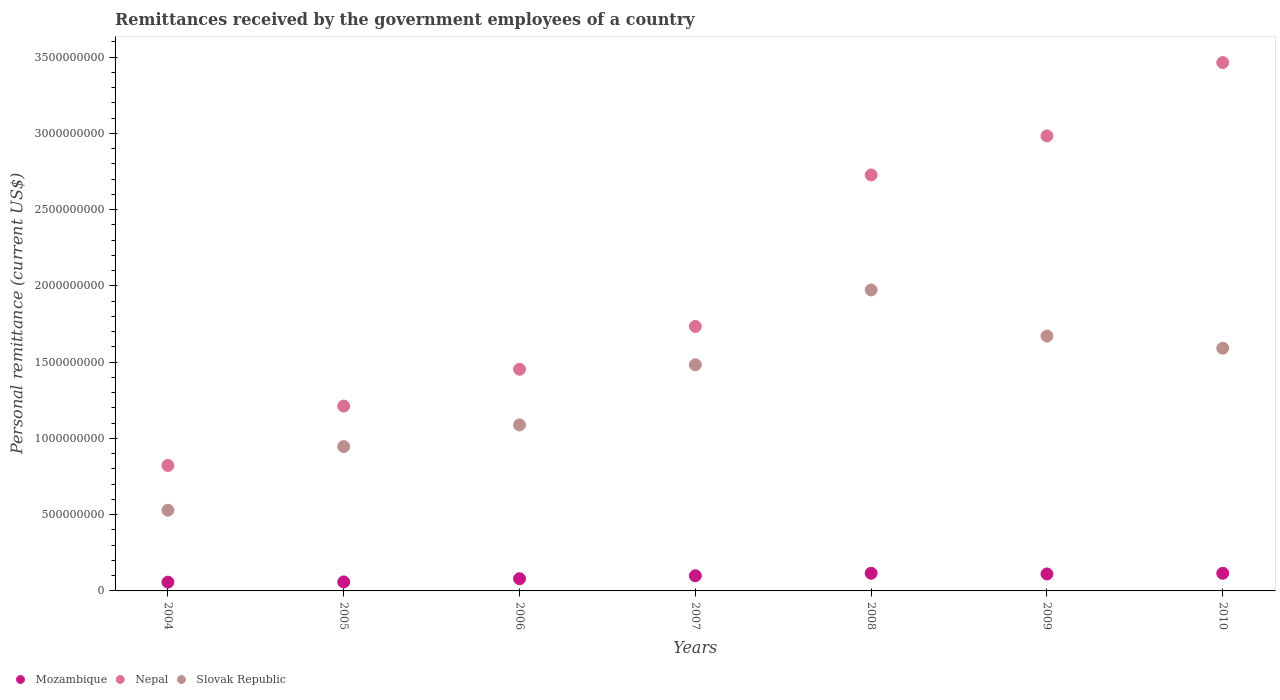How many different coloured dotlines are there?
Your answer should be very brief. 3. What is the remittances received by the government employees in Slovak Republic in 2006?
Offer a terse response. 1.09e+09. Across all years, what is the maximum remittances received by the government employees in Mozambique?
Keep it short and to the point. 1.16e+08. Across all years, what is the minimum remittances received by the government employees in Nepal?
Keep it short and to the point. 8.23e+08. In which year was the remittances received by the government employees in Nepal maximum?
Your answer should be very brief. 2010. In which year was the remittances received by the government employees in Slovak Republic minimum?
Your response must be concise. 2004. What is the total remittances received by the government employees in Nepal in the graph?
Make the answer very short. 1.44e+1. What is the difference between the remittances received by the government employees in Slovak Republic in 2007 and that in 2010?
Ensure brevity in your answer.  -1.09e+08. What is the difference between the remittances received by the government employees in Mozambique in 2009 and the remittances received by the government employees in Nepal in 2007?
Make the answer very short. -1.62e+09. What is the average remittances received by the government employees in Nepal per year?
Give a very brief answer. 2.06e+09. In the year 2008, what is the difference between the remittances received by the government employees in Slovak Republic and remittances received by the government employees in Nepal?
Provide a short and direct response. -7.54e+08. What is the ratio of the remittances received by the government employees in Nepal in 2008 to that in 2010?
Offer a terse response. 0.79. What is the difference between the highest and the second highest remittances received by the government employees in Slovak Republic?
Provide a short and direct response. 3.02e+08. What is the difference between the highest and the lowest remittances received by the government employees in Slovak Republic?
Provide a short and direct response. 1.44e+09. In how many years, is the remittances received by the government employees in Mozambique greater than the average remittances received by the government employees in Mozambique taken over all years?
Provide a short and direct response. 4. Is the remittances received by the government employees in Slovak Republic strictly greater than the remittances received by the government employees in Mozambique over the years?
Offer a very short reply. Yes. How many dotlines are there?
Make the answer very short. 3. What is the difference between two consecutive major ticks on the Y-axis?
Provide a succinct answer. 5.00e+08. Does the graph contain any zero values?
Offer a terse response. No. Does the graph contain grids?
Offer a very short reply. No. How many legend labels are there?
Your answer should be very brief. 3. How are the legend labels stacked?
Provide a succinct answer. Horizontal. What is the title of the graph?
Provide a succinct answer. Remittances received by the government employees of a country. What is the label or title of the Y-axis?
Provide a short and direct response. Personal remittance (current US$). What is the Personal remittance (current US$) of Mozambique in 2004?
Offer a terse response. 5.75e+07. What is the Personal remittance (current US$) in Nepal in 2004?
Your answer should be compact. 8.23e+08. What is the Personal remittance (current US$) of Slovak Republic in 2004?
Keep it short and to the point. 5.29e+08. What is the Personal remittance (current US$) of Mozambique in 2005?
Provide a short and direct response. 5.89e+07. What is the Personal remittance (current US$) of Nepal in 2005?
Make the answer very short. 1.21e+09. What is the Personal remittance (current US$) of Slovak Republic in 2005?
Ensure brevity in your answer.  9.46e+08. What is the Personal remittance (current US$) of Mozambique in 2006?
Provide a succinct answer. 8.00e+07. What is the Personal remittance (current US$) of Nepal in 2006?
Give a very brief answer. 1.45e+09. What is the Personal remittance (current US$) of Slovak Republic in 2006?
Provide a short and direct response. 1.09e+09. What is the Personal remittance (current US$) of Mozambique in 2007?
Make the answer very short. 9.94e+07. What is the Personal remittance (current US$) in Nepal in 2007?
Keep it short and to the point. 1.73e+09. What is the Personal remittance (current US$) in Slovak Republic in 2007?
Provide a short and direct response. 1.48e+09. What is the Personal remittance (current US$) of Mozambique in 2008?
Offer a very short reply. 1.16e+08. What is the Personal remittance (current US$) in Nepal in 2008?
Your answer should be very brief. 2.73e+09. What is the Personal remittance (current US$) of Slovak Republic in 2008?
Offer a terse response. 1.97e+09. What is the Personal remittance (current US$) in Mozambique in 2009?
Offer a very short reply. 1.11e+08. What is the Personal remittance (current US$) of Nepal in 2009?
Give a very brief answer. 2.98e+09. What is the Personal remittance (current US$) in Slovak Republic in 2009?
Provide a succinct answer. 1.67e+09. What is the Personal remittance (current US$) in Mozambique in 2010?
Offer a terse response. 1.16e+08. What is the Personal remittance (current US$) of Nepal in 2010?
Offer a terse response. 3.46e+09. What is the Personal remittance (current US$) in Slovak Republic in 2010?
Offer a very short reply. 1.59e+09. Across all years, what is the maximum Personal remittance (current US$) of Mozambique?
Offer a terse response. 1.16e+08. Across all years, what is the maximum Personal remittance (current US$) of Nepal?
Ensure brevity in your answer.  3.46e+09. Across all years, what is the maximum Personal remittance (current US$) in Slovak Republic?
Make the answer very short. 1.97e+09. Across all years, what is the minimum Personal remittance (current US$) of Mozambique?
Your response must be concise. 5.75e+07. Across all years, what is the minimum Personal remittance (current US$) in Nepal?
Your answer should be compact. 8.23e+08. Across all years, what is the minimum Personal remittance (current US$) in Slovak Republic?
Your response must be concise. 5.29e+08. What is the total Personal remittance (current US$) in Mozambique in the graph?
Ensure brevity in your answer.  6.38e+08. What is the total Personal remittance (current US$) of Nepal in the graph?
Ensure brevity in your answer.  1.44e+1. What is the total Personal remittance (current US$) in Slovak Republic in the graph?
Keep it short and to the point. 9.28e+09. What is the difference between the Personal remittance (current US$) in Mozambique in 2004 and that in 2005?
Your response must be concise. -1.37e+06. What is the difference between the Personal remittance (current US$) in Nepal in 2004 and that in 2005?
Your answer should be compact. -3.89e+08. What is the difference between the Personal remittance (current US$) in Slovak Republic in 2004 and that in 2005?
Offer a very short reply. -4.17e+08. What is the difference between the Personal remittance (current US$) of Mozambique in 2004 and that in 2006?
Provide a short and direct response. -2.25e+07. What is the difference between the Personal remittance (current US$) of Nepal in 2004 and that in 2006?
Keep it short and to the point. -6.31e+08. What is the difference between the Personal remittance (current US$) in Slovak Republic in 2004 and that in 2006?
Your response must be concise. -5.59e+08. What is the difference between the Personal remittance (current US$) of Mozambique in 2004 and that in 2007?
Offer a very short reply. -4.19e+07. What is the difference between the Personal remittance (current US$) in Nepal in 2004 and that in 2007?
Make the answer very short. -9.11e+08. What is the difference between the Personal remittance (current US$) of Slovak Republic in 2004 and that in 2007?
Give a very brief answer. -9.54e+08. What is the difference between the Personal remittance (current US$) of Mozambique in 2004 and that in 2008?
Make the answer very short. -5.82e+07. What is the difference between the Personal remittance (current US$) of Nepal in 2004 and that in 2008?
Ensure brevity in your answer.  -1.90e+09. What is the difference between the Personal remittance (current US$) in Slovak Republic in 2004 and that in 2008?
Your response must be concise. -1.44e+09. What is the difference between the Personal remittance (current US$) in Mozambique in 2004 and that in 2009?
Make the answer very short. -5.36e+07. What is the difference between the Personal remittance (current US$) in Nepal in 2004 and that in 2009?
Offer a very short reply. -2.16e+09. What is the difference between the Personal remittance (current US$) of Slovak Republic in 2004 and that in 2009?
Make the answer very short. -1.14e+09. What is the difference between the Personal remittance (current US$) of Mozambique in 2004 and that in 2010?
Give a very brief answer. -5.83e+07. What is the difference between the Personal remittance (current US$) of Nepal in 2004 and that in 2010?
Your answer should be very brief. -2.64e+09. What is the difference between the Personal remittance (current US$) in Slovak Republic in 2004 and that in 2010?
Ensure brevity in your answer.  -1.06e+09. What is the difference between the Personal remittance (current US$) of Mozambique in 2005 and that in 2006?
Your response must be concise. -2.11e+07. What is the difference between the Personal remittance (current US$) of Nepal in 2005 and that in 2006?
Your answer should be very brief. -2.41e+08. What is the difference between the Personal remittance (current US$) in Slovak Republic in 2005 and that in 2006?
Your answer should be very brief. -1.42e+08. What is the difference between the Personal remittance (current US$) in Mozambique in 2005 and that in 2007?
Your answer should be compact. -4.05e+07. What is the difference between the Personal remittance (current US$) in Nepal in 2005 and that in 2007?
Offer a very short reply. -5.22e+08. What is the difference between the Personal remittance (current US$) of Slovak Republic in 2005 and that in 2007?
Give a very brief answer. -5.36e+08. What is the difference between the Personal remittance (current US$) of Mozambique in 2005 and that in 2008?
Your answer should be compact. -5.69e+07. What is the difference between the Personal remittance (current US$) in Nepal in 2005 and that in 2008?
Your response must be concise. -1.52e+09. What is the difference between the Personal remittance (current US$) of Slovak Republic in 2005 and that in 2008?
Ensure brevity in your answer.  -1.03e+09. What is the difference between the Personal remittance (current US$) in Mozambique in 2005 and that in 2009?
Offer a terse response. -5.22e+07. What is the difference between the Personal remittance (current US$) in Nepal in 2005 and that in 2009?
Offer a terse response. -1.77e+09. What is the difference between the Personal remittance (current US$) in Slovak Republic in 2005 and that in 2009?
Your answer should be very brief. -7.24e+08. What is the difference between the Personal remittance (current US$) in Mozambique in 2005 and that in 2010?
Make the answer very short. -5.69e+07. What is the difference between the Personal remittance (current US$) in Nepal in 2005 and that in 2010?
Your answer should be compact. -2.25e+09. What is the difference between the Personal remittance (current US$) of Slovak Republic in 2005 and that in 2010?
Provide a succinct answer. -6.45e+08. What is the difference between the Personal remittance (current US$) in Mozambique in 2006 and that in 2007?
Your answer should be very brief. -1.94e+07. What is the difference between the Personal remittance (current US$) in Nepal in 2006 and that in 2007?
Your response must be concise. -2.81e+08. What is the difference between the Personal remittance (current US$) of Slovak Republic in 2006 and that in 2007?
Provide a short and direct response. -3.94e+08. What is the difference between the Personal remittance (current US$) of Mozambique in 2006 and that in 2008?
Offer a very short reply. -3.57e+07. What is the difference between the Personal remittance (current US$) in Nepal in 2006 and that in 2008?
Provide a short and direct response. -1.27e+09. What is the difference between the Personal remittance (current US$) in Slovak Republic in 2006 and that in 2008?
Provide a succinct answer. -8.85e+08. What is the difference between the Personal remittance (current US$) of Mozambique in 2006 and that in 2009?
Give a very brief answer. -3.11e+07. What is the difference between the Personal remittance (current US$) of Nepal in 2006 and that in 2009?
Your response must be concise. -1.53e+09. What is the difference between the Personal remittance (current US$) of Slovak Republic in 2006 and that in 2009?
Give a very brief answer. -5.83e+08. What is the difference between the Personal remittance (current US$) of Mozambique in 2006 and that in 2010?
Your response must be concise. -3.57e+07. What is the difference between the Personal remittance (current US$) of Nepal in 2006 and that in 2010?
Make the answer very short. -2.01e+09. What is the difference between the Personal remittance (current US$) of Slovak Republic in 2006 and that in 2010?
Your answer should be very brief. -5.03e+08. What is the difference between the Personal remittance (current US$) of Mozambique in 2007 and that in 2008?
Provide a short and direct response. -1.64e+07. What is the difference between the Personal remittance (current US$) of Nepal in 2007 and that in 2008?
Provide a short and direct response. -9.93e+08. What is the difference between the Personal remittance (current US$) of Slovak Republic in 2007 and that in 2008?
Offer a terse response. -4.91e+08. What is the difference between the Personal remittance (current US$) of Mozambique in 2007 and that in 2009?
Offer a very short reply. -1.17e+07. What is the difference between the Personal remittance (current US$) of Nepal in 2007 and that in 2009?
Give a very brief answer. -1.25e+09. What is the difference between the Personal remittance (current US$) in Slovak Republic in 2007 and that in 2009?
Keep it short and to the point. -1.88e+08. What is the difference between the Personal remittance (current US$) in Mozambique in 2007 and that in 2010?
Provide a succinct answer. -1.64e+07. What is the difference between the Personal remittance (current US$) of Nepal in 2007 and that in 2010?
Provide a short and direct response. -1.73e+09. What is the difference between the Personal remittance (current US$) of Slovak Republic in 2007 and that in 2010?
Offer a very short reply. -1.09e+08. What is the difference between the Personal remittance (current US$) of Mozambique in 2008 and that in 2009?
Keep it short and to the point. 4.62e+06. What is the difference between the Personal remittance (current US$) of Nepal in 2008 and that in 2009?
Give a very brief answer. -2.56e+08. What is the difference between the Personal remittance (current US$) in Slovak Republic in 2008 and that in 2009?
Make the answer very short. 3.02e+08. What is the difference between the Personal remittance (current US$) of Mozambique in 2008 and that in 2010?
Provide a short and direct response. -3.33e+04. What is the difference between the Personal remittance (current US$) of Nepal in 2008 and that in 2010?
Keep it short and to the point. -7.37e+08. What is the difference between the Personal remittance (current US$) in Slovak Republic in 2008 and that in 2010?
Make the answer very short. 3.82e+08. What is the difference between the Personal remittance (current US$) in Mozambique in 2009 and that in 2010?
Your response must be concise. -4.65e+06. What is the difference between the Personal remittance (current US$) in Nepal in 2009 and that in 2010?
Make the answer very short. -4.81e+08. What is the difference between the Personal remittance (current US$) of Slovak Republic in 2009 and that in 2010?
Your answer should be compact. 7.96e+07. What is the difference between the Personal remittance (current US$) in Mozambique in 2004 and the Personal remittance (current US$) in Nepal in 2005?
Provide a short and direct response. -1.15e+09. What is the difference between the Personal remittance (current US$) in Mozambique in 2004 and the Personal remittance (current US$) in Slovak Republic in 2005?
Offer a very short reply. -8.89e+08. What is the difference between the Personal remittance (current US$) of Nepal in 2004 and the Personal remittance (current US$) of Slovak Republic in 2005?
Provide a succinct answer. -1.24e+08. What is the difference between the Personal remittance (current US$) in Mozambique in 2004 and the Personal remittance (current US$) in Nepal in 2006?
Make the answer very short. -1.40e+09. What is the difference between the Personal remittance (current US$) in Mozambique in 2004 and the Personal remittance (current US$) in Slovak Republic in 2006?
Give a very brief answer. -1.03e+09. What is the difference between the Personal remittance (current US$) of Nepal in 2004 and the Personal remittance (current US$) of Slovak Republic in 2006?
Provide a short and direct response. -2.66e+08. What is the difference between the Personal remittance (current US$) in Mozambique in 2004 and the Personal remittance (current US$) in Nepal in 2007?
Keep it short and to the point. -1.68e+09. What is the difference between the Personal remittance (current US$) of Mozambique in 2004 and the Personal remittance (current US$) of Slovak Republic in 2007?
Your answer should be compact. -1.43e+09. What is the difference between the Personal remittance (current US$) of Nepal in 2004 and the Personal remittance (current US$) of Slovak Republic in 2007?
Provide a succinct answer. -6.60e+08. What is the difference between the Personal remittance (current US$) in Mozambique in 2004 and the Personal remittance (current US$) in Nepal in 2008?
Your answer should be compact. -2.67e+09. What is the difference between the Personal remittance (current US$) of Mozambique in 2004 and the Personal remittance (current US$) of Slovak Republic in 2008?
Your answer should be very brief. -1.92e+09. What is the difference between the Personal remittance (current US$) of Nepal in 2004 and the Personal remittance (current US$) of Slovak Republic in 2008?
Your answer should be compact. -1.15e+09. What is the difference between the Personal remittance (current US$) in Mozambique in 2004 and the Personal remittance (current US$) in Nepal in 2009?
Your answer should be very brief. -2.93e+09. What is the difference between the Personal remittance (current US$) in Mozambique in 2004 and the Personal remittance (current US$) in Slovak Republic in 2009?
Offer a very short reply. -1.61e+09. What is the difference between the Personal remittance (current US$) of Nepal in 2004 and the Personal remittance (current US$) of Slovak Republic in 2009?
Offer a terse response. -8.48e+08. What is the difference between the Personal remittance (current US$) in Mozambique in 2004 and the Personal remittance (current US$) in Nepal in 2010?
Your answer should be very brief. -3.41e+09. What is the difference between the Personal remittance (current US$) of Mozambique in 2004 and the Personal remittance (current US$) of Slovak Republic in 2010?
Provide a succinct answer. -1.53e+09. What is the difference between the Personal remittance (current US$) in Nepal in 2004 and the Personal remittance (current US$) in Slovak Republic in 2010?
Offer a terse response. -7.69e+08. What is the difference between the Personal remittance (current US$) of Mozambique in 2005 and the Personal remittance (current US$) of Nepal in 2006?
Provide a short and direct response. -1.39e+09. What is the difference between the Personal remittance (current US$) of Mozambique in 2005 and the Personal remittance (current US$) of Slovak Republic in 2006?
Your response must be concise. -1.03e+09. What is the difference between the Personal remittance (current US$) in Nepal in 2005 and the Personal remittance (current US$) in Slovak Republic in 2006?
Ensure brevity in your answer.  1.24e+08. What is the difference between the Personal remittance (current US$) of Mozambique in 2005 and the Personal remittance (current US$) of Nepal in 2007?
Keep it short and to the point. -1.67e+09. What is the difference between the Personal remittance (current US$) in Mozambique in 2005 and the Personal remittance (current US$) in Slovak Republic in 2007?
Provide a succinct answer. -1.42e+09. What is the difference between the Personal remittance (current US$) of Nepal in 2005 and the Personal remittance (current US$) of Slovak Republic in 2007?
Your answer should be very brief. -2.71e+08. What is the difference between the Personal remittance (current US$) of Mozambique in 2005 and the Personal remittance (current US$) of Nepal in 2008?
Your answer should be compact. -2.67e+09. What is the difference between the Personal remittance (current US$) in Mozambique in 2005 and the Personal remittance (current US$) in Slovak Republic in 2008?
Provide a short and direct response. -1.91e+09. What is the difference between the Personal remittance (current US$) in Nepal in 2005 and the Personal remittance (current US$) in Slovak Republic in 2008?
Offer a very short reply. -7.61e+08. What is the difference between the Personal remittance (current US$) of Mozambique in 2005 and the Personal remittance (current US$) of Nepal in 2009?
Provide a succinct answer. -2.92e+09. What is the difference between the Personal remittance (current US$) of Mozambique in 2005 and the Personal remittance (current US$) of Slovak Republic in 2009?
Offer a very short reply. -1.61e+09. What is the difference between the Personal remittance (current US$) of Nepal in 2005 and the Personal remittance (current US$) of Slovak Republic in 2009?
Offer a terse response. -4.59e+08. What is the difference between the Personal remittance (current US$) of Mozambique in 2005 and the Personal remittance (current US$) of Nepal in 2010?
Give a very brief answer. -3.41e+09. What is the difference between the Personal remittance (current US$) in Mozambique in 2005 and the Personal remittance (current US$) in Slovak Republic in 2010?
Keep it short and to the point. -1.53e+09. What is the difference between the Personal remittance (current US$) in Nepal in 2005 and the Personal remittance (current US$) in Slovak Republic in 2010?
Your response must be concise. -3.79e+08. What is the difference between the Personal remittance (current US$) in Mozambique in 2006 and the Personal remittance (current US$) in Nepal in 2007?
Offer a very short reply. -1.65e+09. What is the difference between the Personal remittance (current US$) of Mozambique in 2006 and the Personal remittance (current US$) of Slovak Republic in 2007?
Your response must be concise. -1.40e+09. What is the difference between the Personal remittance (current US$) in Nepal in 2006 and the Personal remittance (current US$) in Slovak Republic in 2007?
Offer a terse response. -2.94e+07. What is the difference between the Personal remittance (current US$) in Mozambique in 2006 and the Personal remittance (current US$) in Nepal in 2008?
Keep it short and to the point. -2.65e+09. What is the difference between the Personal remittance (current US$) of Mozambique in 2006 and the Personal remittance (current US$) of Slovak Republic in 2008?
Make the answer very short. -1.89e+09. What is the difference between the Personal remittance (current US$) in Nepal in 2006 and the Personal remittance (current US$) in Slovak Republic in 2008?
Give a very brief answer. -5.20e+08. What is the difference between the Personal remittance (current US$) of Mozambique in 2006 and the Personal remittance (current US$) of Nepal in 2009?
Ensure brevity in your answer.  -2.90e+09. What is the difference between the Personal remittance (current US$) in Mozambique in 2006 and the Personal remittance (current US$) in Slovak Republic in 2009?
Make the answer very short. -1.59e+09. What is the difference between the Personal remittance (current US$) in Nepal in 2006 and the Personal remittance (current US$) in Slovak Republic in 2009?
Offer a terse response. -2.18e+08. What is the difference between the Personal remittance (current US$) of Mozambique in 2006 and the Personal remittance (current US$) of Nepal in 2010?
Ensure brevity in your answer.  -3.38e+09. What is the difference between the Personal remittance (current US$) in Mozambique in 2006 and the Personal remittance (current US$) in Slovak Republic in 2010?
Give a very brief answer. -1.51e+09. What is the difference between the Personal remittance (current US$) in Nepal in 2006 and the Personal remittance (current US$) in Slovak Republic in 2010?
Your response must be concise. -1.38e+08. What is the difference between the Personal remittance (current US$) in Mozambique in 2007 and the Personal remittance (current US$) in Nepal in 2008?
Give a very brief answer. -2.63e+09. What is the difference between the Personal remittance (current US$) of Mozambique in 2007 and the Personal remittance (current US$) of Slovak Republic in 2008?
Offer a terse response. -1.87e+09. What is the difference between the Personal remittance (current US$) in Nepal in 2007 and the Personal remittance (current US$) in Slovak Republic in 2008?
Provide a short and direct response. -2.39e+08. What is the difference between the Personal remittance (current US$) of Mozambique in 2007 and the Personal remittance (current US$) of Nepal in 2009?
Give a very brief answer. -2.88e+09. What is the difference between the Personal remittance (current US$) of Mozambique in 2007 and the Personal remittance (current US$) of Slovak Republic in 2009?
Provide a succinct answer. -1.57e+09. What is the difference between the Personal remittance (current US$) of Nepal in 2007 and the Personal remittance (current US$) of Slovak Republic in 2009?
Ensure brevity in your answer.  6.29e+07. What is the difference between the Personal remittance (current US$) of Mozambique in 2007 and the Personal remittance (current US$) of Nepal in 2010?
Ensure brevity in your answer.  -3.36e+09. What is the difference between the Personal remittance (current US$) of Mozambique in 2007 and the Personal remittance (current US$) of Slovak Republic in 2010?
Your answer should be compact. -1.49e+09. What is the difference between the Personal remittance (current US$) in Nepal in 2007 and the Personal remittance (current US$) in Slovak Republic in 2010?
Keep it short and to the point. 1.43e+08. What is the difference between the Personal remittance (current US$) in Mozambique in 2008 and the Personal remittance (current US$) in Nepal in 2009?
Offer a terse response. -2.87e+09. What is the difference between the Personal remittance (current US$) of Mozambique in 2008 and the Personal remittance (current US$) of Slovak Republic in 2009?
Provide a succinct answer. -1.56e+09. What is the difference between the Personal remittance (current US$) in Nepal in 2008 and the Personal remittance (current US$) in Slovak Republic in 2009?
Provide a short and direct response. 1.06e+09. What is the difference between the Personal remittance (current US$) of Mozambique in 2008 and the Personal remittance (current US$) of Nepal in 2010?
Make the answer very short. -3.35e+09. What is the difference between the Personal remittance (current US$) of Mozambique in 2008 and the Personal remittance (current US$) of Slovak Republic in 2010?
Your answer should be compact. -1.48e+09. What is the difference between the Personal remittance (current US$) in Nepal in 2008 and the Personal remittance (current US$) in Slovak Republic in 2010?
Offer a terse response. 1.14e+09. What is the difference between the Personal remittance (current US$) of Mozambique in 2009 and the Personal remittance (current US$) of Nepal in 2010?
Your answer should be very brief. -3.35e+09. What is the difference between the Personal remittance (current US$) in Mozambique in 2009 and the Personal remittance (current US$) in Slovak Republic in 2010?
Give a very brief answer. -1.48e+09. What is the difference between the Personal remittance (current US$) in Nepal in 2009 and the Personal remittance (current US$) in Slovak Republic in 2010?
Give a very brief answer. 1.39e+09. What is the average Personal remittance (current US$) of Mozambique per year?
Give a very brief answer. 9.12e+07. What is the average Personal remittance (current US$) in Nepal per year?
Make the answer very short. 2.06e+09. What is the average Personal remittance (current US$) in Slovak Republic per year?
Ensure brevity in your answer.  1.33e+09. In the year 2004, what is the difference between the Personal remittance (current US$) in Mozambique and Personal remittance (current US$) in Nepal?
Provide a succinct answer. -7.65e+08. In the year 2004, what is the difference between the Personal remittance (current US$) of Mozambique and Personal remittance (current US$) of Slovak Republic?
Provide a succinct answer. -4.72e+08. In the year 2004, what is the difference between the Personal remittance (current US$) of Nepal and Personal remittance (current US$) of Slovak Republic?
Provide a succinct answer. 2.94e+08. In the year 2005, what is the difference between the Personal remittance (current US$) in Mozambique and Personal remittance (current US$) in Nepal?
Keep it short and to the point. -1.15e+09. In the year 2005, what is the difference between the Personal remittance (current US$) in Mozambique and Personal remittance (current US$) in Slovak Republic?
Give a very brief answer. -8.88e+08. In the year 2005, what is the difference between the Personal remittance (current US$) in Nepal and Personal remittance (current US$) in Slovak Republic?
Your answer should be very brief. 2.65e+08. In the year 2006, what is the difference between the Personal remittance (current US$) of Mozambique and Personal remittance (current US$) of Nepal?
Your answer should be compact. -1.37e+09. In the year 2006, what is the difference between the Personal remittance (current US$) in Mozambique and Personal remittance (current US$) in Slovak Republic?
Keep it short and to the point. -1.01e+09. In the year 2006, what is the difference between the Personal remittance (current US$) in Nepal and Personal remittance (current US$) in Slovak Republic?
Your answer should be very brief. 3.65e+08. In the year 2007, what is the difference between the Personal remittance (current US$) in Mozambique and Personal remittance (current US$) in Nepal?
Keep it short and to the point. -1.63e+09. In the year 2007, what is the difference between the Personal remittance (current US$) of Mozambique and Personal remittance (current US$) of Slovak Republic?
Provide a short and direct response. -1.38e+09. In the year 2007, what is the difference between the Personal remittance (current US$) in Nepal and Personal remittance (current US$) in Slovak Republic?
Provide a succinct answer. 2.51e+08. In the year 2008, what is the difference between the Personal remittance (current US$) in Mozambique and Personal remittance (current US$) in Nepal?
Your answer should be compact. -2.61e+09. In the year 2008, what is the difference between the Personal remittance (current US$) of Mozambique and Personal remittance (current US$) of Slovak Republic?
Ensure brevity in your answer.  -1.86e+09. In the year 2008, what is the difference between the Personal remittance (current US$) in Nepal and Personal remittance (current US$) in Slovak Republic?
Provide a succinct answer. 7.54e+08. In the year 2009, what is the difference between the Personal remittance (current US$) of Mozambique and Personal remittance (current US$) of Nepal?
Provide a short and direct response. -2.87e+09. In the year 2009, what is the difference between the Personal remittance (current US$) of Mozambique and Personal remittance (current US$) of Slovak Republic?
Keep it short and to the point. -1.56e+09. In the year 2009, what is the difference between the Personal remittance (current US$) in Nepal and Personal remittance (current US$) in Slovak Republic?
Your answer should be very brief. 1.31e+09. In the year 2010, what is the difference between the Personal remittance (current US$) of Mozambique and Personal remittance (current US$) of Nepal?
Your answer should be very brief. -3.35e+09. In the year 2010, what is the difference between the Personal remittance (current US$) in Mozambique and Personal remittance (current US$) in Slovak Republic?
Ensure brevity in your answer.  -1.48e+09. In the year 2010, what is the difference between the Personal remittance (current US$) in Nepal and Personal remittance (current US$) in Slovak Republic?
Your answer should be compact. 1.87e+09. What is the ratio of the Personal remittance (current US$) of Mozambique in 2004 to that in 2005?
Offer a terse response. 0.98. What is the ratio of the Personal remittance (current US$) of Nepal in 2004 to that in 2005?
Offer a very short reply. 0.68. What is the ratio of the Personal remittance (current US$) in Slovak Republic in 2004 to that in 2005?
Provide a succinct answer. 0.56. What is the ratio of the Personal remittance (current US$) in Mozambique in 2004 to that in 2006?
Offer a terse response. 0.72. What is the ratio of the Personal remittance (current US$) of Nepal in 2004 to that in 2006?
Provide a short and direct response. 0.57. What is the ratio of the Personal remittance (current US$) of Slovak Republic in 2004 to that in 2006?
Your response must be concise. 0.49. What is the ratio of the Personal remittance (current US$) of Mozambique in 2004 to that in 2007?
Ensure brevity in your answer.  0.58. What is the ratio of the Personal remittance (current US$) in Nepal in 2004 to that in 2007?
Offer a very short reply. 0.47. What is the ratio of the Personal remittance (current US$) of Slovak Republic in 2004 to that in 2007?
Offer a very short reply. 0.36. What is the ratio of the Personal remittance (current US$) in Mozambique in 2004 to that in 2008?
Ensure brevity in your answer.  0.5. What is the ratio of the Personal remittance (current US$) of Nepal in 2004 to that in 2008?
Ensure brevity in your answer.  0.3. What is the ratio of the Personal remittance (current US$) in Slovak Republic in 2004 to that in 2008?
Make the answer very short. 0.27. What is the ratio of the Personal remittance (current US$) in Mozambique in 2004 to that in 2009?
Offer a terse response. 0.52. What is the ratio of the Personal remittance (current US$) in Nepal in 2004 to that in 2009?
Your answer should be compact. 0.28. What is the ratio of the Personal remittance (current US$) in Slovak Republic in 2004 to that in 2009?
Offer a very short reply. 0.32. What is the ratio of the Personal remittance (current US$) in Mozambique in 2004 to that in 2010?
Offer a very short reply. 0.5. What is the ratio of the Personal remittance (current US$) in Nepal in 2004 to that in 2010?
Your answer should be very brief. 0.24. What is the ratio of the Personal remittance (current US$) in Slovak Republic in 2004 to that in 2010?
Your answer should be compact. 0.33. What is the ratio of the Personal remittance (current US$) of Mozambique in 2005 to that in 2006?
Provide a succinct answer. 0.74. What is the ratio of the Personal remittance (current US$) of Nepal in 2005 to that in 2006?
Provide a short and direct response. 0.83. What is the ratio of the Personal remittance (current US$) in Slovak Republic in 2005 to that in 2006?
Your response must be concise. 0.87. What is the ratio of the Personal remittance (current US$) in Mozambique in 2005 to that in 2007?
Your response must be concise. 0.59. What is the ratio of the Personal remittance (current US$) in Nepal in 2005 to that in 2007?
Keep it short and to the point. 0.7. What is the ratio of the Personal remittance (current US$) of Slovak Republic in 2005 to that in 2007?
Your answer should be compact. 0.64. What is the ratio of the Personal remittance (current US$) of Mozambique in 2005 to that in 2008?
Provide a succinct answer. 0.51. What is the ratio of the Personal remittance (current US$) in Nepal in 2005 to that in 2008?
Offer a very short reply. 0.44. What is the ratio of the Personal remittance (current US$) of Slovak Republic in 2005 to that in 2008?
Make the answer very short. 0.48. What is the ratio of the Personal remittance (current US$) in Mozambique in 2005 to that in 2009?
Make the answer very short. 0.53. What is the ratio of the Personal remittance (current US$) in Nepal in 2005 to that in 2009?
Offer a terse response. 0.41. What is the ratio of the Personal remittance (current US$) of Slovak Republic in 2005 to that in 2009?
Offer a very short reply. 0.57. What is the ratio of the Personal remittance (current US$) of Mozambique in 2005 to that in 2010?
Keep it short and to the point. 0.51. What is the ratio of the Personal remittance (current US$) of Nepal in 2005 to that in 2010?
Offer a terse response. 0.35. What is the ratio of the Personal remittance (current US$) in Slovak Republic in 2005 to that in 2010?
Give a very brief answer. 0.59. What is the ratio of the Personal remittance (current US$) of Mozambique in 2006 to that in 2007?
Ensure brevity in your answer.  0.81. What is the ratio of the Personal remittance (current US$) of Nepal in 2006 to that in 2007?
Give a very brief answer. 0.84. What is the ratio of the Personal remittance (current US$) in Slovak Republic in 2006 to that in 2007?
Provide a succinct answer. 0.73. What is the ratio of the Personal remittance (current US$) in Mozambique in 2006 to that in 2008?
Keep it short and to the point. 0.69. What is the ratio of the Personal remittance (current US$) of Nepal in 2006 to that in 2008?
Your answer should be very brief. 0.53. What is the ratio of the Personal remittance (current US$) in Slovak Republic in 2006 to that in 2008?
Your answer should be compact. 0.55. What is the ratio of the Personal remittance (current US$) of Mozambique in 2006 to that in 2009?
Make the answer very short. 0.72. What is the ratio of the Personal remittance (current US$) in Nepal in 2006 to that in 2009?
Keep it short and to the point. 0.49. What is the ratio of the Personal remittance (current US$) of Slovak Republic in 2006 to that in 2009?
Ensure brevity in your answer.  0.65. What is the ratio of the Personal remittance (current US$) of Mozambique in 2006 to that in 2010?
Give a very brief answer. 0.69. What is the ratio of the Personal remittance (current US$) in Nepal in 2006 to that in 2010?
Your answer should be compact. 0.42. What is the ratio of the Personal remittance (current US$) in Slovak Republic in 2006 to that in 2010?
Provide a succinct answer. 0.68. What is the ratio of the Personal remittance (current US$) of Mozambique in 2007 to that in 2008?
Keep it short and to the point. 0.86. What is the ratio of the Personal remittance (current US$) of Nepal in 2007 to that in 2008?
Your answer should be compact. 0.64. What is the ratio of the Personal remittance (current US$) in Slovak Republic in 2007 to that in 2008?
Your answer should be very brief. 0.75. What is the ratio of the Personal remittance (current US$) in Mozambique in 2007 to that in 2009?
Give a very brief answer. 0.89. What is the ratio of the Personal remittance (current US$) of Nepal in 2007 to that in 2009?
Your answer should be compact. 0.58. What is the ratio of the Personal remittance (current US$) in Slovak Republic in 2007 to that in 2009?
Offer a very short reply. 0.89. What is the ratio of the Personal remittance (current US$) of Mozambique in 2007 to that in 2010?
Your answer should be very brief. 0.86. What is the ratio of the Personal remittance (current US$) in Nepal in 2007 to that in 2010?
Offer a terse response. 0.5. What is the ratio of the Personal remittance (current US$) in Slovak Republic in 2007 to that in 2010?
Keep it short and to the point. 0.93. What is the ratio of the Personal remittance (current US$) of Mozambique in 2008 to that in 2009?
Ensure brevity in your answer.  1.04. What is the ratio of the Personal remittance (current US$) of Nepal in 2008 to that in 2009?
Offer a terse response. 0.91. What is the ratio of the Personal remittance (current US$) in Slovak Republic in 2008 to that in 2009?
Provide a short and direct response. 1.18. What is the ratio of the Personal remittance (current US$) of Mozambique in 2008 to that in 2010?
Provide a succinct answer. 1. What is the ratio of the Personal remittance (current US$) in Nepal in 2008 to that in 2010?
Give a very brief answer. 0.79. What is the ratio of the Personal remittance (current US$) in Slovak Republic in 2008 to that in 2010?
Your answer should be compact. 1.24. What is the ratio of the Personal remittance (current US$) in Mozambique in 2009 to that in 2010?
Provide a succinct answer. 0.96. What is the ratio of the Personal remittance (current US$) in Nepal in 2009 to that in 2010?
Make the answer very short. 0.86. What is the difference between the highest and the second highest Personal remittance (current US$) in Mozambique?
Make the answer very short. 3.33e+04. What is the difference between the highest and the second highest Personal remittance (current US$) in Nepal?
Provide a succinct answer. 4.81e+08. What is the difference between the highest and the second highest Personal remittance (current US$) of Slovak Republic?
Offer a terse response. 3.02e+08. What is the difference between the highest and the lowest Personal remittance (current US$) of Mozambique?
Your answer should be very brief. 5.83e+07. What is the difference between the highest and the lowest Personal remittance (current US$) in Nepal?
Keep it short and to the point. 2.64e+09. What is the difference between the highest and the lowest Personal remittance (current US$) in Slovak Republic?
Your response must be concise. 1.44e+09. 